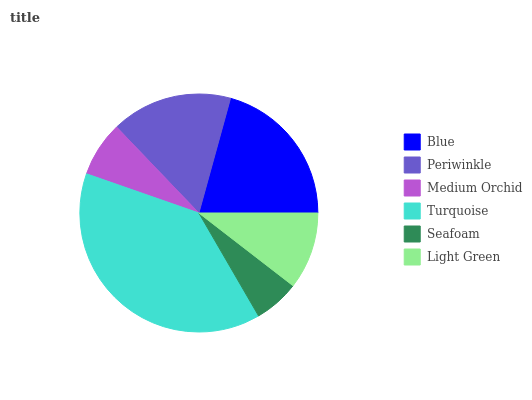Is Seafoam the minimum?
Answer yes or no. Yes. Is Turquoise the maximum?
Answer yes or no. Yes. Is Periwinkle the minimum?
Answer yes or no. No. Is Periwinkle the maximum?
Answer yes or no. No. Is Blue greater than Periwinkle?
Answer yes or no. Yes. Is Periwinkle less than Blue?
Answer yes or no. Yes. Is Periwinkle greater than Blue?
Answer yes or no. No. Is Blue less than Periwinkle?
Answer yes or no. No. Is Periwinkle the high median?
Answer yes or no. Yes. Is Light Green the low median?
Answer yes or no. Yes. Is Light Green the high median?
Answer yes or no. No. Is Blue the low median?
Answer yes or no. No. 